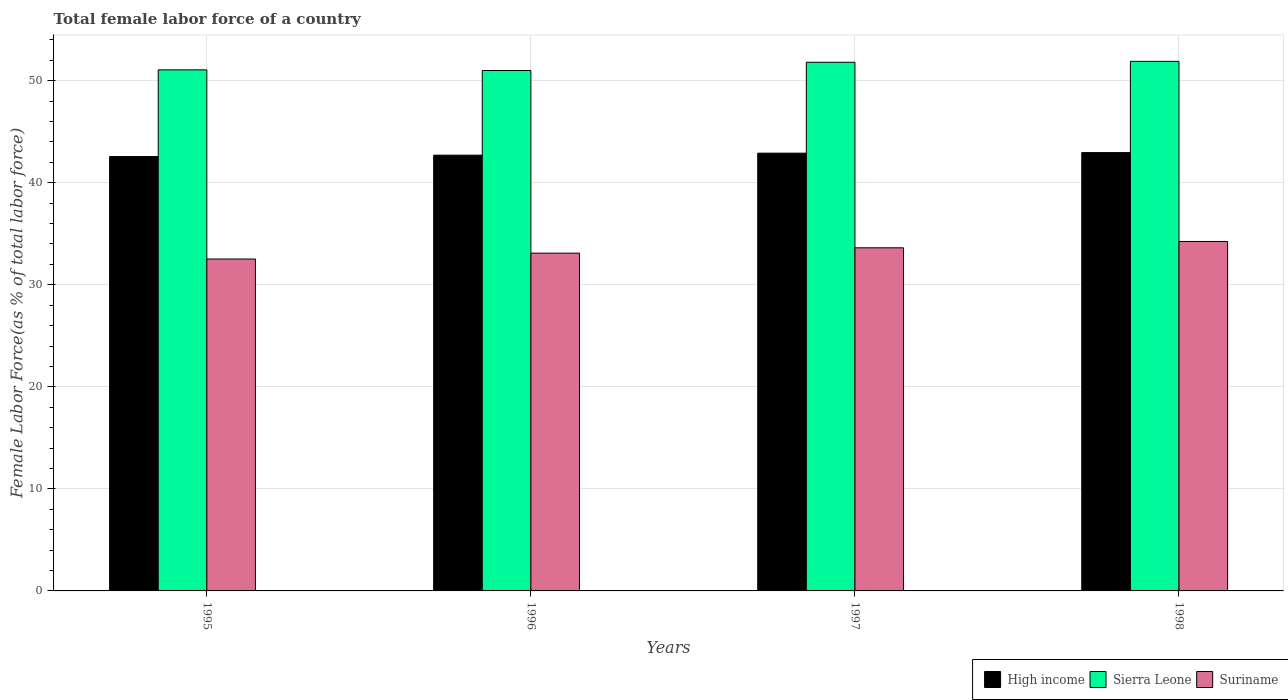How many groups of bars are there?
Keep it short and to the point. 4. How many bars are there on the 1st tick from the right?
Give a very brief answer. 3. In how many cases, is the number of bars for a given year not equal to the number of legend labels?
Your answer should be compact. 0. What is the percentage of female labor force in High income in 1997?
Offer a terse response. 42.9. Across all years, what is the maximum percentage of female labor force in Suriname?
Keep it short and to the point. 34.24. Across all years, what is the minimum percentage of female labor force in Suriname?
Provide a succinct answer. 32.53. In which year was the percentage of female labor force in Sierra Leone minimum?
Keep it short and to the point. 1996. What is the total percentage of female labor force in Sierra Leone in the graph?
Keep it short and to the point. 205.76. What is the difference between the percentage of female labor force in High income in 1996 and that in 1997?
Ensure brevity in your answer.  -0.2. What is the difference between the percentage of female labor force in Suriname in 1997 and the percentage of female labor force in High income in 1998?
Ensure brevity in your answer.  -9.33. What is the average percentage of female labor force in Sierra Leone per year?
Your response must be concise. 51.44. In the year 1996, what is the difference between the percentage of female labor force in Suriname and percentage of female labor force in Sierra Leone?
Keep it short and to the point. -17.9. In how many years, is the percentage of female labor force in Sierra Leone greater than 6 %?
Your answer should be very brief. 4. What is the ratio of the percentage of female labor force in Suriname in 1995 to that in 1998?
Keep it short and to the point. 0.95. Is the percentage of female labor force in Sierra Leone in 1997 less than that in 1998?
Keep it short and to the point. Yes. What is the difference between the highest and the second highest percentage of female labor force in Suriname?
Provide a succinct answer. 0.62. What is the difference between the highest and the lowest percentage of female labor force in Sierra Leone?
Offer a very short reply. 0.89. Is the sum of the percentage of female labor force in Sierra Leone in 1996 and 1997 greater than the maximum percentage of female labor force in High income across all years?
Offer a very short reply. Yes. What does the 3rd bar from the left in 1996 represents?
Ensure brevity in your answer.  Suriname. What does the 1st bar from the right in 1997 represents?
Your answer should be compact. Suriname. Is it the case that in every year, the sum of the percentage of female labor force in High income and percentage of female labor force in Sierra Leone is greater than the percentage of female labor force in Suriname?
Your answer should be very brief. Yes. Are all the bars in the graph horizontal?
Your answer should be compact. No. What is the difference between two consecutive major ticks on the Y-axis?
Ensure brevity in your answer.  10. Does the graph contain any zero values?
Offer a very short reply. No. How many legend labels are there?
Ensure brevity in your answer.  3. What is the title of the graph?
Provide a short and direct response. Total female labor force of a country. Does "Norway" appear as one of the legend labels in the graph?
Keep it short and to the point. No. What is the label or title of the Y-axis?
Provide a succinct answer. Female Labor Force(as % of total labor force). What is the Female Labor Force(as % of total labor force) of High income in 1995?
Your answer should be compact. 42.57. What is the Female Labor Force(as % of total labor force) of Sierra Leone in 1995?
Provide a succinct answer. 51.06. What is the Female Labor Force(as % of total labor force) in Suriname in 1995?
Your answer should be very brief. 32.53. What is the Female Labor Force(as % of total labor force) of High income in 1996?
Keep it short and to the point. 42.7. What is the Female Labor Force(as % of total labor force) of Sierra Leone in 1996?
Ensure brevity in your answer.  51. What is the Female Labor Force(as % of total labor force) in Suriname in 1996?
Your answer should be very brief. 33.1. What is the Female Labor Force(as % of total labor force) of High income in 1997?
Offer a very short reply. 42.9. What is the Female Labor Force(as % of total labor force) of Sierra Leone in 1997?
Offer a very short reply. 51.8. What is the Female Labor Force(as % of total labor force) in Suriname in 1997?
Provide a succinct answer. 33.62. What is the Female Labor Force(as % of total labor force) in High income in 1998?
Provide a short and direct response. 42.95. What is the Female Labor Force(as % of total labor force) in Sierra Leone in 1998?
Keep it short and to the point. 51.89. What is the Female Labor Force(as % of total labor force) of Suriname in 1998?
Offer a very short reply. 34.24. Across all years, what is the maximum Female Labor Force(as % of total labor force) in High income?
Make the answer very short. 42.95. Across all years, what is the maximum Female Labor Force(as % of total labor force) in Sierra Leone?
Keep it short and to the point. 51.89. Across all years, what is the maximum Female Labor Force(as % of total labor force) of Suriname?
Keep it short and to the point. 34.24. Across all years, what is the minimum Female Labor Force(as % of total labor force) of High income?
Provide a short and direct response. 42.57. Across all years, what is the minimum Female Labor Force(as % of total labor force) of Sierra Leone?
Keep it short and to the point. 51. Across all years, what is the minimum Female Labor Force(as % of total labor force) of Suriname?
Make the answer very short. 32.53. What is the total Female Labor Force(as % of total labor force) of High income in the graph?
Offer a terse response. 171.12. What is the total Female Labor Force(as % of total labor force) of Sierra Leone in the graph?
Give a very brief answer. 205.76. What is the total Female Labor Force(as % of total labor force) in Suriname in the graph?
Your answer should be very brief. 133.49. What is the difference between the Female Labor Force(as % of total labor force) in High income in 1995 and that in 1996?
Make the answer very short. -0.14. What is the difference between the Female Labor Force(as % of total labor force) in Sierra Leone in 1995 and that in 1996?
Ensure brevity in your answer.  0.06. What is the difference between the Female Labor Force(as % of total labor force) of Suriname in 1995 and that in 1996?
Offer a very short reply. -0.58. What is the difference between the Female Labor Force(as % of total labor force) of High income in 1995 and that in 1997?
Provide a succinct answer. -0.33. What is the difference between the Female Labor Force(as % of total labor force) of Sierra Leone in 1995 and that in 1997?
Provide a short and direct response. -0.74. What is the difference between the Female Labor Force(as % of total labor force) of Suriname in 1995 and that in 1997?
Provide a succinct answer. -1.1. What is the difference between the Female Labor Force(as % of total labor force) of High income in 1995 and that in 1998?
Your answer should be very brief. -0.39. What is the difference between the Female Labor Force(as % of total labor force) of Sierra Leone in 1995 and that in 1998?
Offer a very short reply. -0.83. What is the difference between the Female Labor Force(as % of total labor force) of Suriname in 1995 and that in 1998?
Offer a very short reply. -1.72. What is the difference between the Female Labor Force(as % of total labor force) of High income in 1996 and that in 1997?
Give a very brief answer. -0.2. What is the difference between the Female Labor Force(as % of total labor force) in Sierra Leone in 1996 and that in 1997?
Give a very brief answer. -0.8. What is the difference between the Female Labor Force(as % of total labor force) of Suriname in 1996 and that in 1997?
Provide a succinct answer. -0.52. What is the difference between the Female Labor Force(as % of total labor force) of High income in 1996 and that in 1998?
Your answer should be compact. -0.25. What is the difference between the Female Labor Force(as % of total labor force) of Sierra Leone in 1996 and that in 1998?
Your answer should be very brief. -0.89. What is the difference between the Female Labor Force(as % of total labor force) of Suriname in 1996 and that in 1998?
Your response must be concise. -1.14. What is the difference between the Female Labor Force(as % of total labor force) in High income in 1997 and that in 1998?
Provide a short and direct response. -0.06. What is the difference between the Female Labor Force(as % of total labor force) of Sierra Leone in 1997 and that in 1998?
Ensure brevity in your answer.  -0.09. What is the difference between the Female Labor Force(as % of total labor force) of Suriname in 1997 and that in 1998?
Offer a terse response. -0.62. What is the difference between the Female Labor Force(as % of total labor force) of High income in 1995 and the Female Labor Force(as % of total labor force) of Sierra Leone in 1996?
Provide a succinct answer. -8.43. What is the difference between the Female Labor Force(as % of total labor force) in High income in 1995 and the Female Labor Force(as % of total labor force) in Suriname in 1996?
Your answer should be compact. 9.47. What is the difference between the Female Labor Force(as % of total labor force) of Sierra Leone in 1995 and the Female Labor Force(as % of total labor force) of Suriname in 1996?
Provide a short and direct response. 17.96. What is the difference between the Female Labor Force(as % of total labor force) of High income in 1995 and the Female Labor Force(as % of total labor force) of Sierra Leone in 1997?
Your response must be concise. -9.24. What is the difference between the Female Labor Force(as % of total labor force) in High income in 1995 and the Female Labor Force(as % of total labor force) in Suriname in 1997?
Give a very brief answer. 8.94. What is the difference between the Female Labor Force(as % of total labor force) of Sierra Leone in 1995 and the Female Labor Force(as % of total labor force) of Suriname in 1997?
Your response must be concise. 17.44. What is the difference between the Female Labor Force(as % of total labor force) in High income in 1995 and the Female Labor Force(as % of total labor force) in Sierra Leone in 1998?
Your answer should be very brief. -9.33. What is the difference between the Female Labor Force(as % of total labor force) of High income in 1995 and the Female Labor Force(as % of total labor force) of Suriname in 1998?
Provide a succinct answer. 8.32. What is the difference between the Female Labor Force(as % of total labor force) of Sierra Leone in 1995 and the Female Labor Force(as % of total labor force) of Suriname in 1998?
Give a very brief answer. 16.82. What is the difference between the Female Labor Force(as % of total labor force) of High income in 1996 and the Female Labor Force(as % of total labor force) of Sierra Leone in 1997?
Your answer should be very brief. -9.1. What is the difference between the Female Labor Force(as % of total labor force) in High income in 1996 and the Female Labor Force(as % of total labor force) in Suriname in 1997?
Keep it short and to the point. 9.08. What is the difference between the Female Labor Force(as % of total labor force) of Sierra Leone in 1996 and the Female Labor Force(as % of total labor force) of Suriname in 1997?
Your answer should be very brief. 17.38. What is the difference between the Female Labor Force(as % of total labor force) of High income in 1996 and the Female Labor Force(as % of total labor force) of Sierra Leone in 1998?
Ensure brevity in your answer.  -9.19. What is the difference between the Female Labor Force(as % of total labor force) of High income in 1996 and the Female Labor Force(as % of total labor force) of Suriname in 1998?
Offer a terse response. 8.46. What is the difference between the Female Labor Force(as % of total labor force) of Sierra Leone in 1996 and the Female Labor Force(as % of total labor force) of Suriname in 1998?
Provide a succinct answer. 16.76. What is the difference between the Female Labor Force(as % of total labor force) of High income in 1997 and the Female Labor Force(as % of total labor force) of Sierra Leone in 1998?
Give a very brief answer. -9. What is the difference between the Female Labor Force(as % of total labor force) of High income in 1997 and the Female Labor Force(as % of total labor force) of Suriname in 1998?
Provide a short and direct response. 8.65. What is the difference between the Female Labor Force(as % of total labor force) in Sierra Leone in 1997 and the Female Labor Force(as % of total labor force) in Suriname in 1998?
Make the answer very short. 17.56. What is the average Female Labor Force(as % of total labor force) in High income per year?
Offer a terse response. 42.78. What is the average Female Labor Force(as % of total labor force) in Sierra Leone per year?
Ensure brevity in your answer.  51.44. What is the average Female Labor Force(as % of total labor force) of Suriname per year?
Give a very brief answer. 33.37. In the year 1995, what is the difference between the Female Labor Force(as % of total labor force) of High income and Female Labor Force(as % of total labor force) of Sierra Leone?
Your answer should be compact. -8.5. In the year 1995, what is the difference between the Female Labor Force(as % of total labor force) in High income and Female Labor Force(as % of total labor force) in Suriname?
Your response must be concise. 10.04. In the year 1995, what is the difference between the Female Labor Force(as % of total labor force) of Sierra Leone and Female Labor Force(as % of total labor force) of Suriname?
Ensure brevity in your answer.  18.54. In the year 1996, what is the difference between the Female Labor Force(as % of total labor force) of High income and Female Labor Force(as % of total labor force) of Sierra Leone?
Ensure brevity in your answer.  -8.3. In the year 1996, what is the difference between the Female Labor Force(as % of total labor force) of High income and Female Labor Force(as % of total labor force) of Suriname?
Your answer should be compact. 9.6. In the year 1996, what is the difference between the Female Labor Force(as % of total labor force) in Sierra Leone and Female Labor Force(as % of total labor force) in Suriname?
Provide a succinct answer. 17.9. In the year 1997, what is the difference between the Female Labor Force(as % of total labor force) in High income and Female Labor Force(as % of total labor force) in Sierra Leone?
Provide a short and direct response. -8.91. In the year 1997, what is the difference between the Female Labor Force(as % of total labor force) of High income and Female Labor Force(as % of total labor force) of Suriname?
Your answer should be compact. 9.27. In the year 1997, what is the difference between the Female Labor Force(as % of total labor force) of Sierra Leone and Female Labor Force(as % of total labor force) of Suriname?
Offer a terse response. 18.18. In the year 1998, what is the difference between the Female Labor Force(as % of total labor force) of High income and Female Labor Force(as % of total labor force) of Sierra Leone?
Give a very brief answer. -8.94. In the year 1998, what is the difference between the Female Labor Force(as % of total labor force) in High income and Female Labor Force(as % of total labor force) in Suriname?
Ensure brevity in your answer.  8.71. In the year 1998, what is the difference between the Female Labor Force(as % of total labor force) of Sierra Leone and Female Labor Force(as % of total labor force) of Suriname?
Your answer should be compact. 17.65. What is the ratio of the Female Labor Force(as % of total labor force) in Sierra Leone in 1995 to that in 1996?
Provide a succinct answer. 1. What is the ratio of the Female Labor Force(as % of total labor force) of Suriname in 1995 to that in 1996?
Make the answer very short. 0.98. What is the ratio of the Female Labor Force(as % of total labor force) in High income in 1995 to that in 1997?
Your answer should be very brief. 0.99. What is the ratio of the Female Labor Force(as % of total labor force) of Sierra Leone in 1995 to that in 1997?
Keep it short and to the point. 0.99. What is the ratio of the Female Labor Force(as % of total labor force) in Suriname in 1995 to that in 1997?
Your response must be concise. 0.97. What is the ratio of the Female Labor Force(as % of total labor force) of Sierra Leone in 1995 to that in 1998?
Your answer should be very brief. 0.98. What is the ratio of the Female Labor Force(as % of total labor force) in Suriname in 1995 to that in 1998?
Provide a short and direct response. 0.95. What is the ratio of the Female Labor Force(as % of total labor force) in High income in 1996 to that in 1997?
Your response must be concise. 1. What is the ratio of the Female Labor Force(as % of total labor force) of Sierra Leone in 1996 to that in 1997?
Your answer should be compact. 0.98. What is the ratio of the Female Labor Force(as % of total labor force) of Suriname in 1996 to that in 1997?
Provide a succinct answer. 0.98. What is the ratio of the Female Labor Force(as % of total labor force) of Sierra Leone in 1996 to that in 1998?
Keep it short and to the point. 0.98. What is the ratio of the Female Labor Force(as % of total labor force) in Suriname in 1996 to that in 1998?
Keep it short and to the point. 0.97. What is the ratio of the Female Labor Force(as % of total labor force) in Sierra Leone in 1997 to that in 1998?
Ensure brevity in your answer.  1. What is the ratio of the Female Labor Force(as % of total labor force) in Suriname in 1997 to that in 1998?
Ensure brevity in your answer.  0.98. What is the difference between the highest and the second highest Female Labor Force(as % of total labor force) of High income?
Your answer should be very brief. 0.06. What is the difference between the highest and the second highest Female Labor Force(as % of total labor force) in Sierra Leone?
Ensure brevity in your answer.  0.09. What is the difference between the highest and the second highest Female Labor Force(as % of total labor force) of Suriname?
Provide a short and direct response. 0.62. What is the difference between the highest and the lowest Female Labor Force(as % of total labor force) of High income?
Ensure brevity in your answer.  0.39. What is the difference between the highest and the lowest Female Labor Force(as % of total labor force) in Sierra Leone?
Ensure brevity in your answer.  0.89. What is the difference between the highest and the lowest Female Labor Force(as % of total labor force) of Suriname?
Keep it short and to the point. 1.72. 